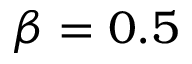<formula> <loc_0><loc_0><loc_500><loc_500>\beta = 0 . 5</formula> 